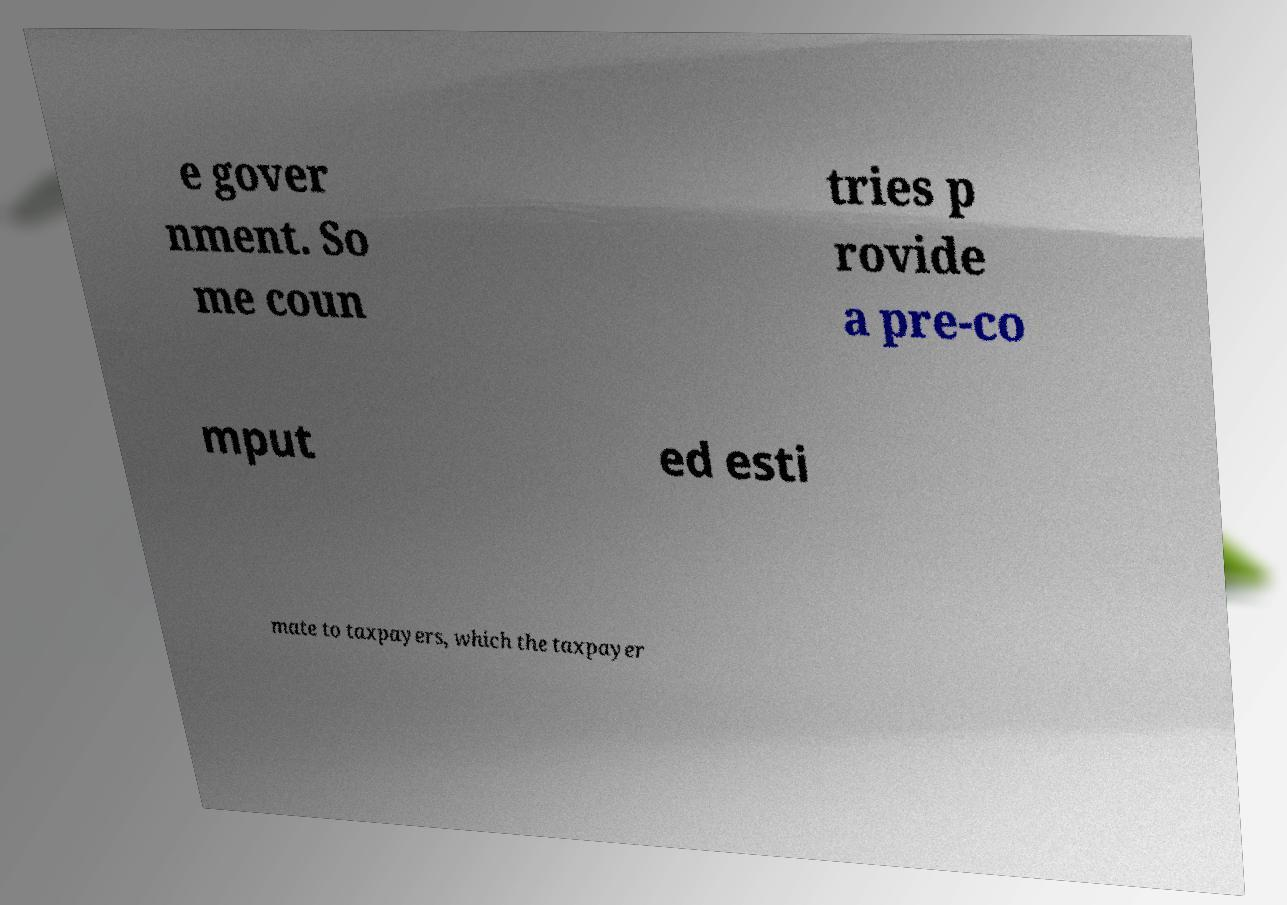Could you assist in decoding the text presented in this image and type it out clearly? e gover nment. So me coun tries p rovide a pre-co mput ed esti mate to taxpayers, which the taxpayer 